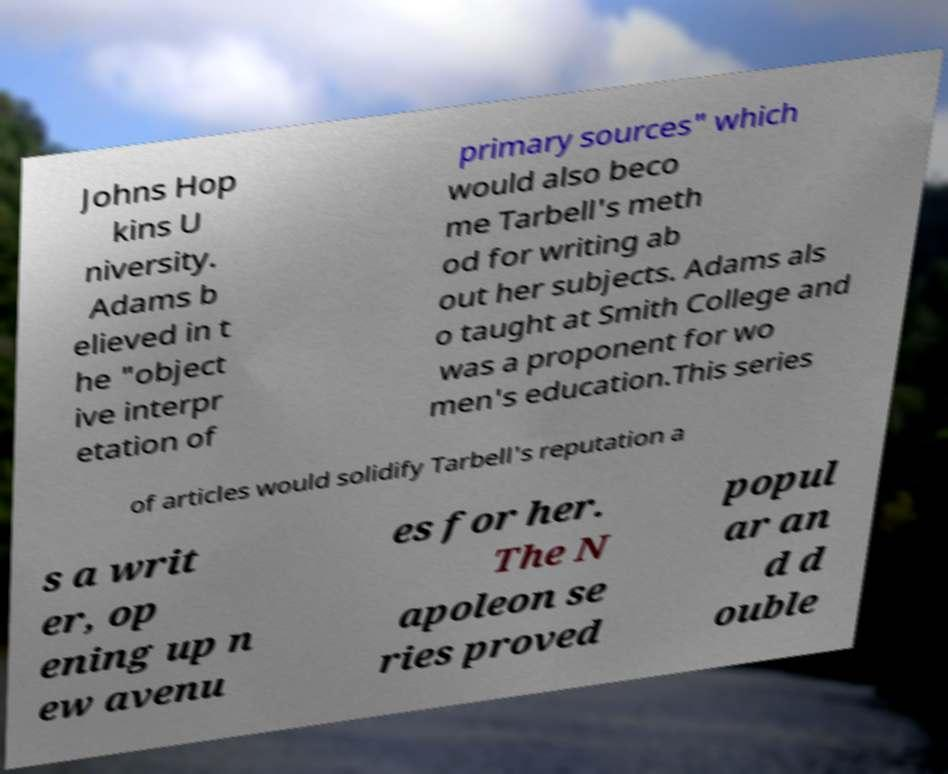Please read and relay the text visible in this image. What does it say? Johns Hop kins U niversity. Adams b elieved in t he "object ive interpr etation of primary sources" which would also beco me Tarbell's meth od for writing ab out her subjects. Adams als o taught at Smith College and was a proponent for wo men's education.This series of articles would solidify Tarbell's reputation a s a writ er, op ening up n ew avenu es for her. The N apoleon se ries proved popul ar an d d ouble 